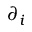Convert formula to latex. <formula><loc_0><loc_0><loc_500><loc_500>\partial _ { i }</formula> 